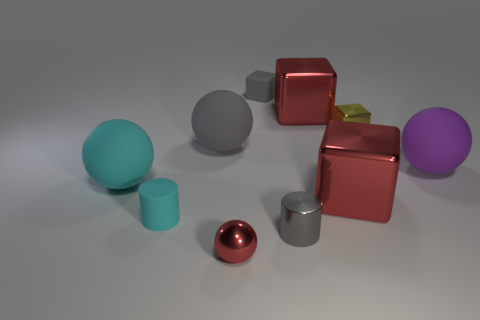What is the tiny block that is left of the gray thing that is in front of the large sphere that is on the right side of the small red shiny ball made of?
Offer a terse response. Rubber. Do the small gray thing in front of the big cyan matte ball and the big gray ball have the same material?
Ensure brevity in your answer.  No. How many gray matte spheres have the same size as the gray metal cylinder?
Offer a very short reply. 0. Is the number of tiny cyan cylinders behind the tiny cyan object greater than the number of small gray shiny cylinders that are left of the big gray thing?
Keep it short and to the point. No. Are there any other metal objects that have the same shape as the large purple thing?
Make the answer very short. Yes. What is the size of the cylinder behind the small cylinder that is on the right side of the small red metallic thing?
Provide a short and direct response. Small. What shape is the tiny rubber object behind the big red metal thing that is behind the small yellow metal block behind the cyan rubber sphere?
Give a very brief answer. Cube. There is a purple object that is made of the same material as the large gray object; what size is it?
Ensure brevity in your answer.  Large. Is the number of small metal cubes greater than the number of small cyan rubber balls?
Offer a very short reply. Yes. What material is the other cylinder that is the same size as the cyan rubber cylinder?
Offer a very short reply. Metal. 